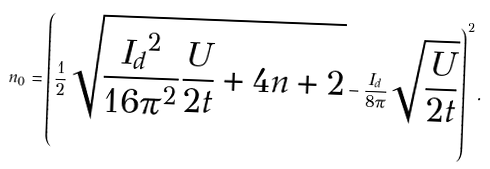<formula> <loc_0><loc_0><loc_500><loc_500>n _ { 0 } = \left ( \frac { 1 } { 2 } \sqrt { \frac { { I _ { d } } ^ { 2 } } { 1 6 \pi ^ { 2 } } \frac { U } { 2 t } + 4 n + 2 } - \frac { I _ { d } } { 8 \pi } \sqrt { \frac { U } { 2 t } } \right ) ^ { 2 } .</formula> 